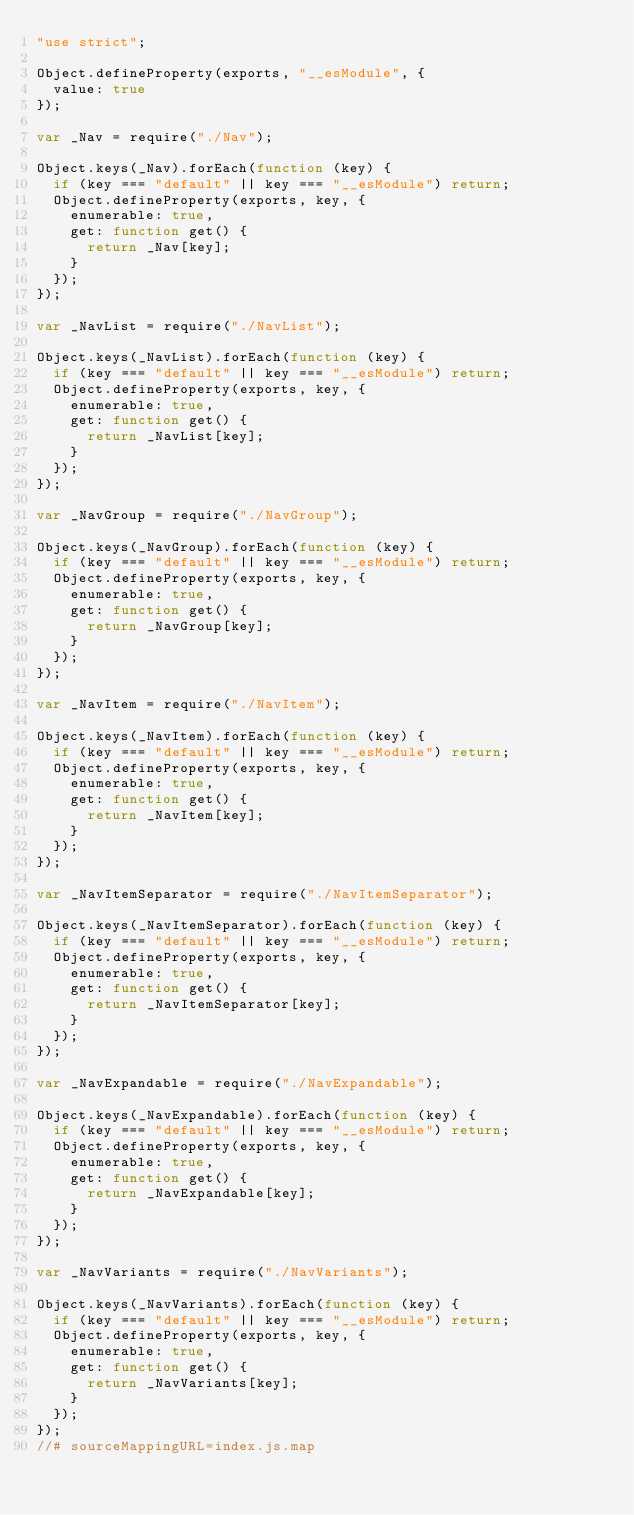<code> <loc_0><loc_0><loc_500><loc_500><_JavaScript_>"use strict";

Object.defineProperty(exports, "__esModule", {
  value: true
});

var _Nav = require("./Nav");

Object.keys(_Nav).forEach(function (key) {
  if (key === "default" || key === "__esModule") return;
  Object.defineProperty(exports, key, {
    enumerable: true,
    get: function get() {
      return _Nav[key];
    }
  });
});

var _NavList = require("./NavList");

Object.keys(_NavList).forEach(function (key) {
  if (key === "default" || key === "__esModule") return;
  Object.defineProperty(exports, key, {
    enumerable: true,
    get: function get() {
      return _NavList[key];
    }
  });
});

var _NavGroup = require("./NavGroup");

Object.keys(_NavGroup).forEach(function (key) {
  if (key === "default" || key === "__esModule") return;
  Object.defineProperty(exports, key, {
    enumerable: true,
    get: function get() {
      return _NavGroup[key];
    }
  });
});

var _NavItem = require("./NavItem");

Object.keys(_NavItem).forEach(function (key) {
  if (key === "default" || key === "__esModule") return;
  Object.defineProperty(exports, key, {
    enumerable: true,
    get: function get() {
      return _NavItem[key];
    }
  });
});

var _NavItemSeparator = require("./NavItemSeparator");

Object.keys(_NavItemSeparator).forEach(function (key) {
  if (key === "default" || key === "__esModule") return;
  Object.defineProperty(exports, key, {
    enumerable: true,
    get: function get() {
      return _NavItemSeparator[key];
    }
  });
});

var _NavExpandable = require("./NavExpandable");

Object.keys(_NavExpandable).forEach(function (key) {
  if (key === "default" || key === "__esModule") return;
  Object.defineProperty(exports, key, {
    enumerable: true,
    get: function get() {
      return _NavExpandable[key];
    }
  });
});

var _NavVariants = require("./NavVariants");

Object.keys(_NavVariants).forEach(function (key) {
  if (key === "default" || key === "__esModule") return;
  Object.defineProperty(exports, key, {
    enumerable: true,
    get: function get() {
      return _NavVariants[key];
    }
  });
});
//# sourceMappingURL=index.js.map</code> 